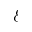<formula> <loc_0><loc_0><loc_500><loc_500>\mathcal { E }</formula> 